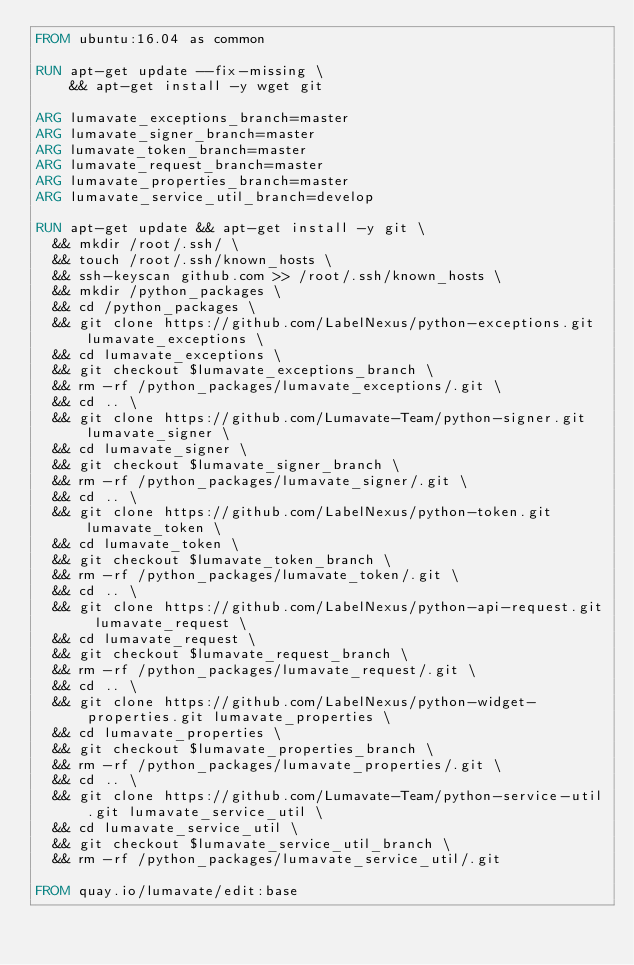Convert code to text. <code><loc_0><loc_0><loc_500><loc_500><_Dockerfile_>FROM ubuntu:16.04 as common

RUN apt-get update --fix-missing \
    && apt-get install -y wget git

ARG lumavate_exceptions_branch=master
ARG lumavate_signer_branch=master
ARG lumavate_token_branch=master
ARG lumavate_request_branch=master
ARG lumavate_properties_branch=master
ARG lumavate_service_util_branch=develop

RUN apt-get update && apt-get install -y git \
  && mkdir /root/.ssh/ \
  && touch /root/.ssh/known_hosts \
  && ssh-keyscan github.com >> /root/.ssh/known_hosts \
  && mkdir /python_packages \
  && cd /python_packages \
  && git clone https://github.com/LabelNexus/python-exceptions.git lumavate_exceptions \
  && cd lumavate_exceptions \
  && git checkout $lumavate_exceptions_branch \
  && rm -rf /python_packages/lumavate_exceptions/.git \
  && cd .. \
  && git clone https://github.com/Lumavate-Team/python-signer.git lumavate_signer \
  && cd lumavate_signer \
  && git checkout $lumavate_signer_branch \
  && rm -rf /python_packages/lumavate_signer/.git \
  && cd .. \
  && git clone https://github.com/LabelNexus/python-token.git lumavate_token \
  && cd lumavate_token \
  && git checkout $lumavate_token_branch \
  && rm -rf /python_packages/lumavate_token/.git \
  && cd .. \
  && git clone https://github.com/LabelNexus/python-api-request.git lumavate_request \
  && cd lumavate_request \
  && git checkout $lumavate_request_branch \
  && rm -rf /python_packages/lumavate_request/.git \
  && cd .. \
  && git clone https://github.com/LabelNexus/python-widget-properties.git lumavate_properties \
  && cd lumavate_properties \
  && git checkout $lumavate_properties_branch \
  && rm -rf /python_packages/lumavate_properties/.git \
  && cd .. \
  && git clone https://github.com/Lumavate-Team/python-service-util.git lumavate_service_util \
  && cd lumavate_service_util \
  && git checkout $lumavate_service_util_branch \
  && rm -rf /python_packages/lumavate_service_util/.git

FROM quay.io/lumavate/edit:base
</code> 